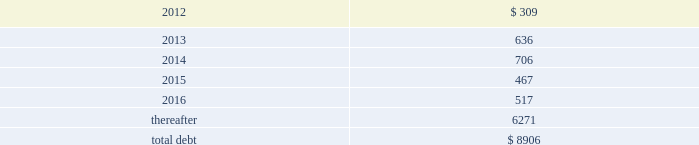Debt maturities 2013 the table presents aggregate debt maturities as of december 31 , 2011 , excluding market value adjustments : millions .
As of both december 31 , 2011 and december 31 , 2010 , we have reclassified as long-term debt approximately $ 100 million of debt due within one year that we intend to refinance .
This reclassification reflects our ability and intent to refinance any short-term borrowings and certain current maturities of long- term debt on a long-term basis .
Mortgaged properties 2013 equipment with a carrying value of approximately $ 2.9 billion and $ 3.2 billion at december 31 , 2011 and 2010 , respectively , served as collateral for capital leases and other types of equipment obligations in accordance with the secured financing arrangements utilized to acquire such railroad equipment .
As a result of the merger of missouri pacific railroad company ( mprr ) with and into uprr on january 1 , 1997 , and pursuant to the underlying indentures for the mprr mortgage bonds , uprr must maintain the same value of assets after the merger in order to comply with the security requirements of the mortgage bonds .
As of the merger date , the value of the mprr assets that secured the mortgage bonds was approximately $ 6.0 billion .
In accordance with the terms of the indentures , this collateral value must be maintained during the entire term of the mortgage bonds irrespective of the outstanding balance of such bonds .
Credit facilities 2013 during the second quarter of 2011 , we replaced our $ 1.9 billion revolving credit facility , which was scheduled to expire in april 2012 , with a new $ 1.8 billion facility that expires in may 2015 ( the facility ) .
The facility is based on substantially similar terms as those in the previous credit facility .
On december 31 , 2011 , we had $ 1.8 billion of credit available under the facility , which is designated for general corporate purposes and supports the issuance of commercial paper .
We did not draw on either facility during 2011 .
Commitment fees and interest rates payable under the facility are similar to fees and rates available to comparably rated , investment-grade borrowers .
The facility allows for borrowings at floating rates based on london interbank offered rates , plus a spread , depending upon our senior unsecured debt ratings .
The facility requires the corporation to maintain a debt-to-net-worth coverage ratio as a condition to making a borrowing .
At december 31 , 2011 , and december 31 , 2010 ( and at all times during the year ) , we were in compliance with this covenant .
The definition of debt used for purposes of calculating the debt-to-net-worth coverage ratio includes , among other things , certain credit arrangements , capital leases , guarantees and unfunded and vested pension benefits under title iv of erisa .
At december 31 , 2011 , the debt-to-net-worth coverage ratio allowed us to carry up to $ 37.2 billion of debt ( as defined in the facility ) , and we had $ 9.5 billion of debt ( as defined in the facility ) outstanding at that date .
Under our current capital plans , we expect to continue to satisfy the debt-to-net-worth coverage ratio ; however , many factors beyond our reasonable control ( including the risk factors in item 1a of this report ) could affect our ability to comply with this provision in the future .
The facility does not include any other financial restrictions , credit rating triggers ( other than rating-dependent pricing ) , or any other provision that could require us to post collateral .
The facility also includes a $ 75 million cross-default provision and a change-of-control provision .
During 2011 , we did not issue or repay any commercial paper and , at december 31 , 2011 , we had no commercial paper outstanding .
Outstanding commercial paper balances are supported by our revolving credit facility but do not reduce the amount of borrowings available under the facility .
Dividend restrictions 2013 our revolving credit facility includes a debt-to-net worth covenant ( discussed in the credit facilities section above ) that , under certain circumstances , restricts the payment of cash .
What percent of total aggregate debt maturities as of december 31 , 2011 are due in 2014? 
Computations: (706 / 8906)
Answer: 0.07927. 